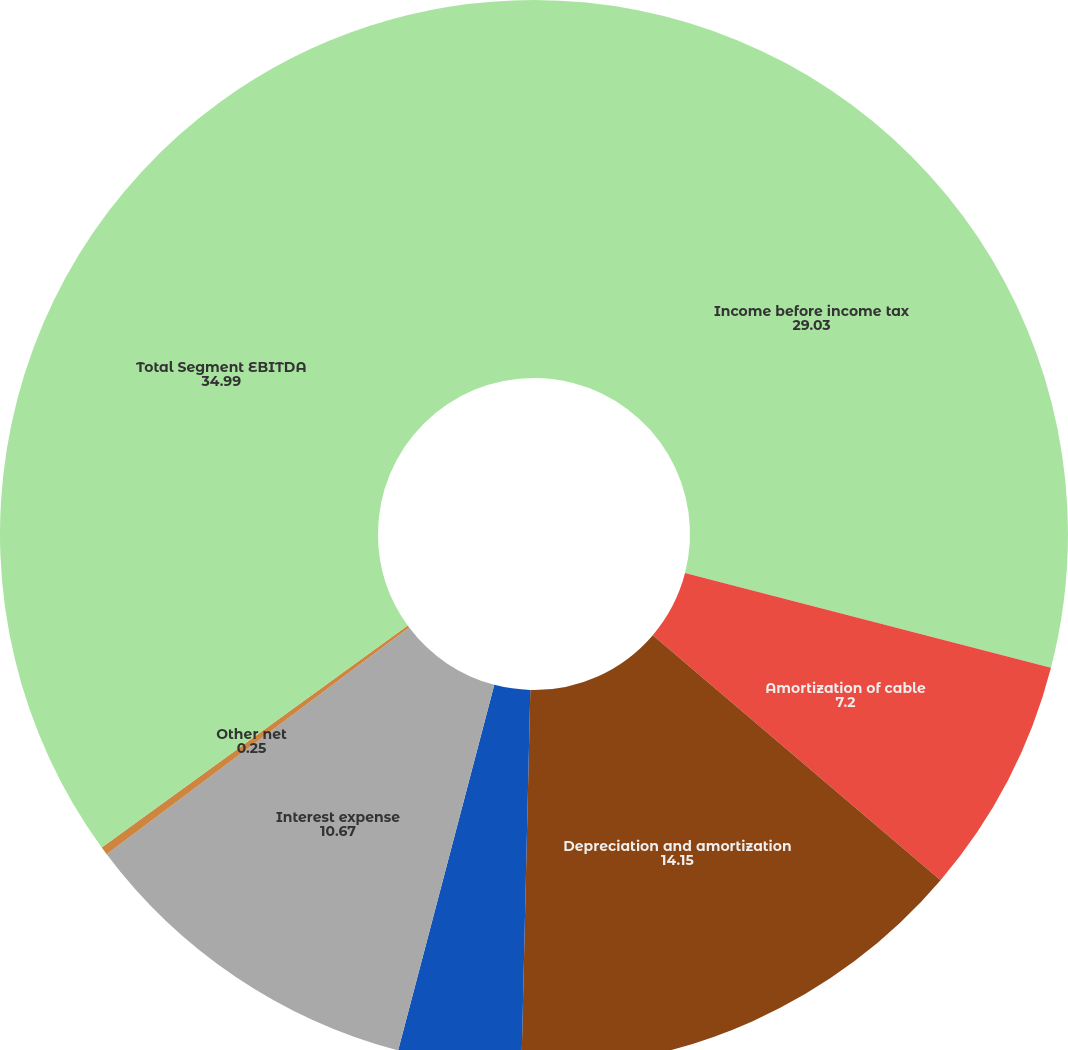Convert chart to OTSL. <chart><loc_0><loc_0><loc_500><loc_500><pie_chart><fcel>Income before income tax<fcel>Amortization of cable<fcel>Depreciation and amortization<fcel>Impairment and restructuring<fcel>Interest expense<fcel>Other net<fcel>Total Segment EBITDA<nl><fcel>29.03%<fcel>7.2%<fcel>14.15%<fcel>3.72%<fcel>10.67%<fcel>0.25%<fcel>34.99%<nl></chart> 